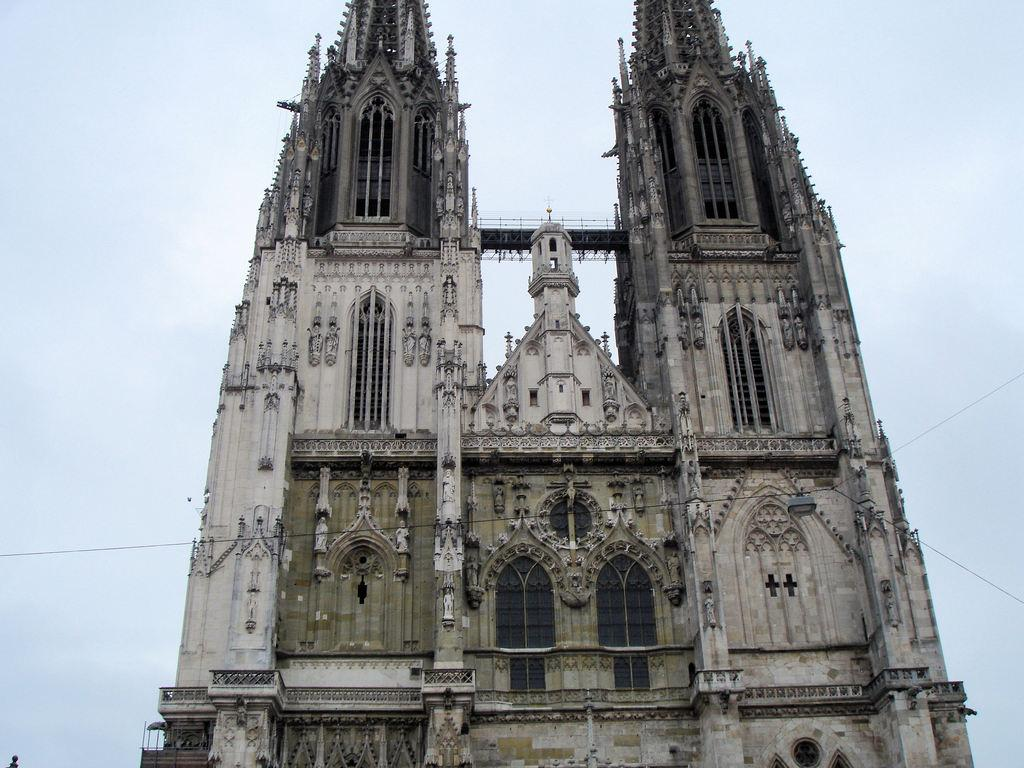What type of structure is visible in the image? There is a building in the image. What can be seen in the sky in the image? There are clouds in the sky in the image. What type of line is visible in the image? There is no line mentioned or visible in the image. What songs can be heard playing in the background of the image? There is no audio or indication of music in the image. 